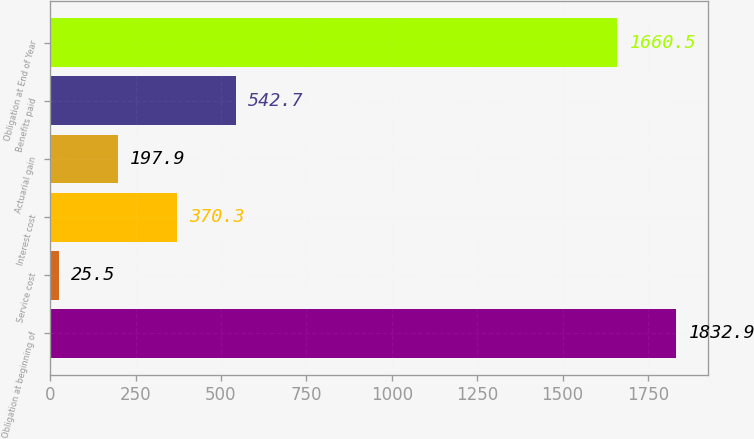Convert chart. <chart><loc_0><loc_0><loc_500><loc_500><bar_chart><fcel>Obligation at beginning of<fcel>Service cost<fcel>Interest cost<fcel>Actuarial gain<fcel>Benefits paid<fcel>Obligation at End of Year<nl><fcel>1832.9<fcel>25.5<fcel>370.3<fcel>197.9<fcel>542.7<fcel>1660.5<nl></chart> 